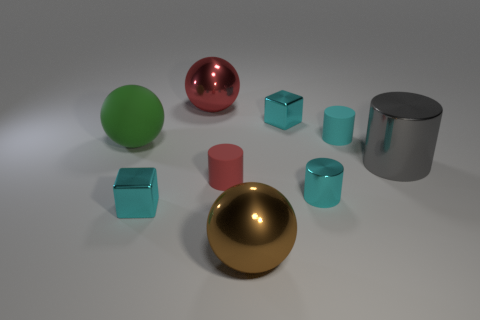Is the cube on the right side of the large brown metal object made of the same material as the large brown sphere that is on the right side of the red metal object?
Make the answer very short. Yes. How many large brown metallic spheres are there?
Offer a very short reply. 1. What number of cyan things are the same shape as the red shiny thing?
Ensure brevity in your answer.  0. Is the big green matte object the same shape as the tiny red thing?
Your answer should be very brief. No. What size is the red matte object?
Your response must be concise. Small. How many rubber things have the same size as the cyan metal cylinder?
Provide a succinct answer. 2. Does the cube that is on the right side of the large brown thing have the same size as the shiny cylinder that is left of the big cylinder?
Ensure brevity in your answer.  Yes. What is the shape of the rubber object that is on the left side of the large red object?
Keep it short and to the point. Sphere. There is a large ball behind the large matte thing that is on the left side of the small cyan rubber cylinder; what is it made of?
Your answer should be very brief. Metal. Is there a large rubber ball that has the same color as the large shiny cylinder?
Provide a short and direct response. No. 